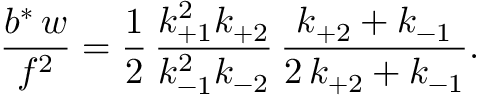<formula> <loc_0><loc_0><loc_500><loc_500>\frac { b ^ { \ast } \, w } { f ^ { 2 } } = \frac { 1 } { 2 } \, \frac { k _ { + 1 } ^ { 2 } k _ { + 2 } } { k _ { - 1 } ^ { 2 } k _ { - 2 } } \, \frac { k _ { + 2 } + k _ { - 1 } } { 2 \, k _ { + 2 } + k _ { - 1 } } .</formula> 